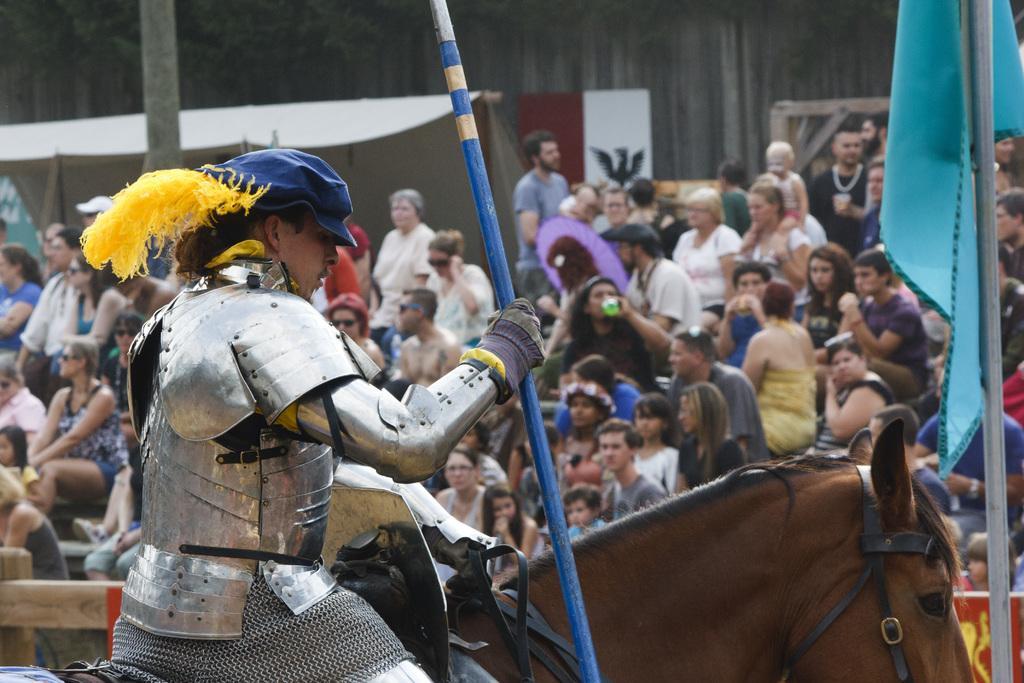Please provide a concise description of this image. This image I can see a person wearing the Armour and a hat is sitting on the horse and holding a weapon in his hand. In the background I can see number of people sitting on the benches and a flag and few people standing and the sky. 